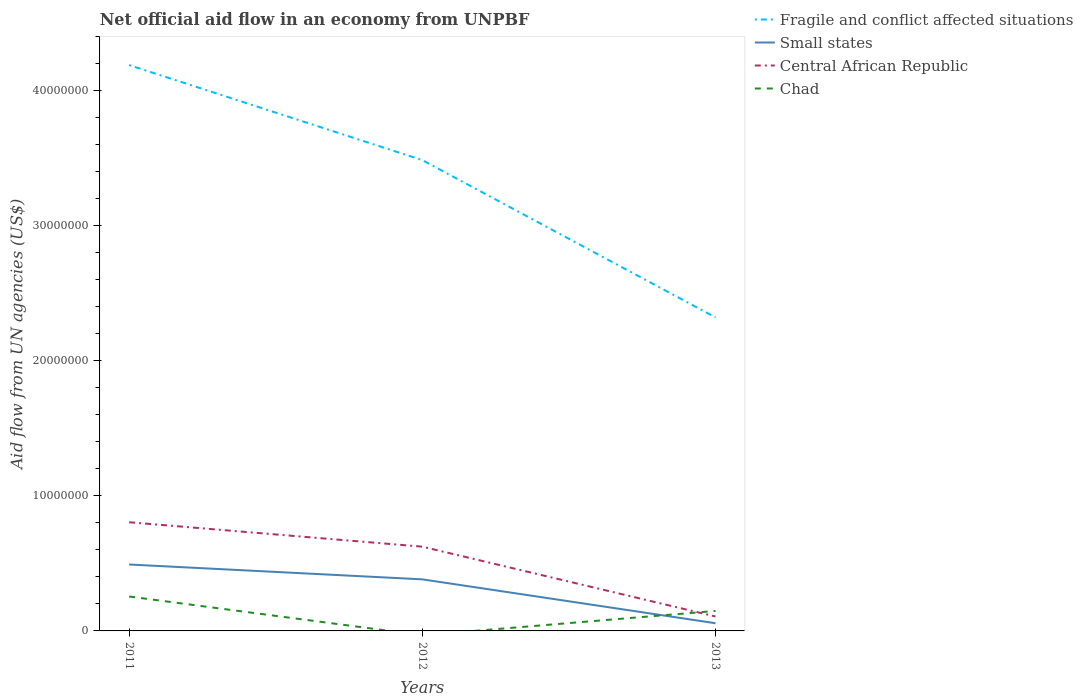Does the line corresponding to Small states intersect with the line corresponding to Central African Republic?
Provide a short and direct response. No. Is the number of lines equal to the number of legend labels?
Offer a very short reply. No. Across all years, what is the maximum net official aid flow in Central African Republic?
Your answer should be compact. 1.07e+06. What is the total net official aid flow in Central African Republic in the graph?
Provide a short and direct response. 6.98e+06. What is the difference between the highest and the second highest net official aid flow in Small states?
Your answer should be very brief. 4.35e+06. What is the difference between the highest and the lowest net official aid flow in Small states?
Make the answer very short. 2. Does the graph contain grids?
Offer a terse response. No. Where does the legend appear in the graph?
Offer a terse response. Top right. What is the title of the graph?
Keep it short and to the point. Net official aid flow in an economy from UNPBF. Does "Norway" appear as one of the legend labels in the graph?
Your answer should be compact. No. What is the label or title of the Y-axis?
Provide a succinct answer. Aid flow from UN agencies (US$). What is the Aid flow from UN agencies (US$) of Fragile and conflict affected situations in 2011?
Offer a terse response. 4.19e+07. What is the Aid flow from UN agencies (US$) of Small states in 2011?
Offer a very short reply. 4.92e+06. What is the Aid flow from UN agencies (US$) in Central African Republic in 2011?
Provide a short and direct response. 8.05e+06. What is the Aid flow from UN agencies (US$) of Chad in 2011?
Offer a very short reply. 2.55e+06. What is the Aid flow from UN agencies (US$) of Fragile and conflict affected situations in 2012?
Ensure brevity in your answer.  3.49e+07. What is the Aid flow from UN agencies (US$) in Small states in 2012?
Give a very brief answer. 3.82e+06. What is the Aid flow from UN agencies (US$) of Central African Republic in 2012?
Provide a succinct answer. 6.24e+06. What is the Aid flow from UN agencies (US$) in Chad in 2012?
Ensure brevity in your answer.  0. What is the Aid flow from UN agencies (US$) of Fragile and conflict affected situations in 2013?
Your answer should be compact. 2.32e+07. What is the Aid flow from UN agencies (US$) of Small states in 2013?
Your response must be concise. 5.70e+05. What is the Aid flow from UN agencies (US$) in Central African Republic in 2013?
Provide a succinct answer. 1.07e+06. What is the Aid flow from UN agencies (US$) in Chad in 2013?
Your answer should be very brief. 1.48e+06. Across all years, what is the maximum Aid flow from UN agencies (US$) in Fragile and conflict affected situations?
Make the answer very short. 4.19e+07. Across all years, what is the maximum Aid flow from UN agencies (US$) in Small states?
Make the answer very short. 4.92e+06. Across all years, what is the maximum Aid flow from UN agencies (US$) of Central African Republic?
Your answer should be compact. 8.05e+06. Across all years, what is the maximum Aid flow from UN agencies (US$) in Chad?
Offer a terse response. 2.55e+06. Across all years, what is the minimum Aid flow from UN agencies (US$) of Fragile and conflict affected situations?
Provide a short and direct response. 2.32e+07. Across all years, what is the minimum Aid flow from UN agencies (US$) in Small states?
Offer a very short reply. 5.70e+05. Across all years, what is the minimum Aid flow from UN agencies (US$) in Central African Republic?
Your response must be concise. 1.07e+06. What is the total Aid flow from UN agencies (US$) in Small states in the graph?
Your answer should be very brief. 9.31e+06. What is the total Aid flow from UN agencies (US$) of Central African Republic in the graph?
Provide a short and direct response. 1.54e+07. What is the total Aid flow from UN agencies (US$) of Chad in the graph?
Your response must be concise. 4.03e+06. What is the difference between the Aid flow from UN agencies (US$) of Fragile and conflict affected situations in 2011 and that in 2012?
Keep it short and to the point. 7.04e+06. What is the difference between the Aid flow from UN agencies (US$) of Small states in 2011 and that in 2012?
Offer a very short reply. 1.10e+06. What is the difference between the Aid flow from UN agencies (US$) in Central African Republic in 2011 and that in 2012?
Your response must be concise. 1.81e+06. What is the difference between the Aid flow from UN agencies (US$) in Fragile and conflict affected situations in 2011 and that in 2013?
Keep it short and to the point. 1.87e+07. What is the difference between the Aid flow from UN agencies (US$) in Small states in 2011 and that in 2013?
Keep it short and to the point. 4.35e+06. What is the difference between the Aid flow from UN agencies (US$) of Central African Republic in 2011 and that in 2013?
Your response must be concise. 6.98e+06. What is the difference between the Aid flow from UN agencies (US$) of Chad in 2011 and that in 2013?
Make the answer very short. 1.07e+06. What is the difference between the Aid flow from UN agencies (US$) of Fragile and conflict affected situations in 2012 and that in 2013?
Your answer should be compact. 1.16e+07. What is the difference between the Aid flow from UN agencies (US$) of Small states in 2012 and that in 2013?
Ensure brevity in your answer.  3.25e+06. What is the difference between the Aid flow from UN agencies (US$) of Central African Republic in 2012 and that in 2013?
Your response must be concise. 5.17e+06. What is the difference between the Aid flow from UN agencies (US$) of Fragile and conflict affected situations in 2011 and the Aid flow from UN agencies (US$) of Small states in 2012?
Your answer should be compact. 3.81e+07. What is the difference between the Aid flow from UN agencies (US$) of Fragile and conflict affected situations in 2011 and the Aid flow from UN agencies (US$) of Central African Republic in 2012?
Provide a succinct answer. 3.57e+07. What is the difference between the Aid flow from UN agencies (US$) of Small states in 2011 and the Aid flow from UN agencies (US$) of Central African Republic in 2012?
Your answer should be compact. -1.32e+06. What is the difference between the Aid flow from UN agencies (US$) in Fragile and conflict affected situations in 2011 and the Aid flow from UN agencies (US$) in Small states in 2013?
Give a very brief answer. 4.13e+07. What is the difference between the Aid flow from UN agencies (US$) in Fragile and conflict affected situations in 2011 and the Aid flow from UN agencies (US$) in Central African Republic in 2013?
Give a very brief answer. 4.08e+07. What is the difference between the Aid flow from UN agencies (US$) in Fragile and conflict affected situations in 2011 and the Aid flow from UN agencies (US$) in Chad in 2013?
Your response must be concise. 4.04e+07. What is the difference between the Aid flow from UN agencies (US$) of Small states in 2011 and the Aid flow from UN agencies (US$) of Central African Republic in 2013?
Offer a terse response. 3.85e+06. What is the difference between the Aid flow from UN agencies (US$) of Small states in 2011 and the Aid flow from UN agencies (US$) of Chad in 2013?
Keep it short and to the point. 3.44e+06. What is the difference between the Aid flow from UN agencies (US$) in Central African Republic in 2011 and the Aid flow from UN agencies (US$) in Chad in 2013?
Offer a very short reply. 6.57e+06. What is the difference between the Aid flow from UN agencies (US$) in Fragile and conflict affected situations in 2012 and the Aid flow from UN agencies (US$) in Small states in 2013?
Provide a short and direct response. 3.43e+07. What is the difference between the Aid flow from UN agencies (US$) in Fragile and conflict affected situations in 2012 and the Aid flow from UN agencies (US$) in Central African Republic in 2013?
Your answer should be compact. 3.38e+07. What is the difference between the Aid flow from UN agencies (US$) of Fragile and conflict affected situations in 2012 and the Aid flow from UN agencies (US$) of Chad in 2013?
Make the answer very short. 3.34e+07. What is the difference between the Aid flow from UN agencies (US$) in Small states in 2012 and the Aid flow from UN agencies (US$) in Central African Republic in 2013?
Your answer should be compact. 2.75e+06. What is the difference between the Aid flow from UN agencies (US$) in Small states in 2012 and the Aid flow from UN agencies (US$) in Chad in 2013?
Your answer should be compact. 2.34e+06. What is the difference between the Aid flow from UN agencies (US$) in Central African Republic in 2012 and the Aid flow from UN agencies (US$) in Chad in 2013?
Give a very brief answer. 4.76e+06. What is the average Aid flow from UN agencies (US$) in Fragile and conflict affected situations per year?
Your response must be concise. 3.33e+07. What is the average Aid flow from UN agencies (US$) of Small states per year?
Offer a very short reply. 3.10e+06. What is the average Aid flow from UN agencies (US$) in Central African Republic per year?
Provide a succinct answer. 5.12e+06. What is the average Aid flow from UN agencies (US$) of Chad per year?
Give a very brief answer. 1.34e+06. In the year 2011, what is the difference between the Aid flow from UN agencies (US$) in Fragile and conflict affected situations and Aid flow from UN agencies (US$) in Small states?
Ensure brevity in your answer.  3.70e+07. In the year 2011, what is the difference between the Aid flow from UN agencies (US$) in Fragile and conflict affected situations and Aid flow from UN agencies (US$) in Central African Republic?
Offer a very short reply. 3.39e+07. In the year 2011, what is the difference between the Aid flow from UN agencies (US$) in Fragile and conflict affected situations and Aid flow from UN agencies (US$) in Chad?
Ensure brevity in your answer.  3.94e+07. In the year 2011, what is the difference between the Aid flow from UN agencies (US$) in Small states and Aid flow from UN agencies (US$) in Central African Republic?
Provide a succinct answer. -3.13e+06. In the year 2011, what is the difference between the Aid flow from UN agencies (US$) in Small states and Aid flow from UN agencies (US$) in Chad?
Your response must be concise. 2.37e+06. In the year 2011, what is the difference between the Aid flow from UN agencies (US$) in Central African Republic and Aid flow from UN agencies (US$) in Chad?
Ensure brevity in your answer.  5.50e+06. In the year 2012, what is the difference between the Aid flow from UN agencies (US$) in Fragile and conflict affected situations and Aid flow from UN agencies (US$) in Small states?
Your answer should be compact. 3.10e+07. In the year 2012, what is the difference between the Aid flow from UN agencies (US$) of Fragile and conflict affected situations and Aid flow from UN agencies (US$) of Central African Republic?
Provide a short and direct response. 2.86e+07. In the year 2012, what is the difference between the Aid flow from UN agencies (US$) in Small states and Aid flow from UN agencies (US$) in Central African Republic?
Your answer should be very brief. -2.42e+06. In the year 2013, what is the difference between the Aid flow from UN agencies (US$) in Fragile and conflict affected situations and Aid flow from UN agencies (US$) in Small states?
Your answer should be very brief. 2.26e+07. In the year 2013, what is the difference between the Aid flow from UN agencies (US$) of Fragile and conflict affected situations and Aid flow from UN agencies (US$) of Central African Republic?
Give a very brief answer. 2.22e+07. In the year 2013, what is the difference between the Aid flow from UN agencies (US$) of Fragile and conflict affected situations and Aid flow from UN agencies (US$) of Chad?
Provide a short and direct response. 2.17e+07. In the year 2013, what is the difference between the Aid flow from UN agencies (US$) of Small states and Aid flow from UN agencies (US$) of Central African Republic?
Keep it short and to the point. -5.00e+05. In the year 2013, what is the difference between the Aid flow from UN agencies (US$) of Small states and Aid flow from UN agencies (US$) of Chad?
Ensure brevity in your answer.  -9.10e+05. In the year 2013, what is the difference between the Aid flow from UN agencies (US$) of Central African Republic and Aid flow from UN agencies (US$) of Chad?
Ensure brevity in your answer.  -4.10e+05. What is the ratio of the Aid flow from UN agencies (US$) in Fragile and conflict affected situations in 2011 to that in 2012?
Offer a very short reply. 1.2. What is the ratio of the Aid flow from UN agencies (US$) of Small states in 2011 to that in 2012?
Provide a succinct answer. 1.29. What is the ratio of the Aid flow from UN agencies (US$) of Central African Republic in 2011 to that in 2012?
Your answer should be very brief. 1.29. What is the ratio of the Aid flow from UN agencies (US$) in Fragile and conflict affected situations in 2011 to that in 2013?
Offer a terse response. 1.8. What is the ratio of the Aid flow from UN agencies (US$) of Small states in 2011 to that in 2013?
Give a very brief answer. 8.63. What is the ratio of the Aid flow from UN agencies (US$) in Central African Republic in 2011 to that in 2013?
Your answer should be compact. 7.52. What is the ratio of the Aid flow from UN agencies (US$) of Chad in 2011 to that in 2013?
Your answer should be very brief. 1.72. What is the ratio of the Aid flow from UN agencies (US$) in Fragile and conflict affected situations in 2012 to that in 2013?
Provide a short and direct response. 1.5. What is the ratio of the Aid flow from UN agencies (US$) of Small states in 2012 to that in 2013?
Offer a very short reply. 6.7. What is the ratio of the Aid flow from UN agencies (US$) in Central African Republic in 2012 to that in 2013?
Make the answer very short. 5.83. What is the difference between the highest and the second highest Aid flow from UN agencies (US$) of Fragile and conflict affected situations?
Your response must be concise. 7.04e+06. What is the difference between the highest and the second highest Aid flow from UN agencies (US$) of Small states?
Make the answer very short. 1.10e+06. What is the difference between the highest and the second highest Aid flow from UN agencies (US$) in Central African Republic?
Offer a very short reply. 1.81e+06. What is the difference between the highest and the lowest Aid flow from UN agencies (US$) of Fragile and conflict affected situations?
Provide a short and direct response. 1.87e+07. What is the difference between the highest and the lowest Aid flow from UN agencies (US$) in Small states?
Give a very brief answer. 4.35e+06. What is the difference between the highest and the lowest Aid flow from UN agencies (US$) of Central African Republic?
Offer a terse response. 6.98e+06. What is the difference between the highest and the lowest Aid flow from UN agencies (US$) of Chad?
Provide a succinct answer. 2.55e+06. 